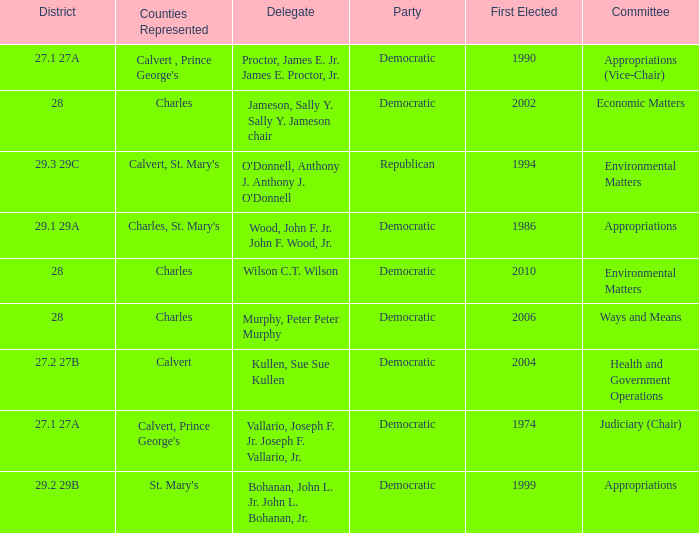Which was the district that had first elected greater than 2006 and is democratic? 28.0. 